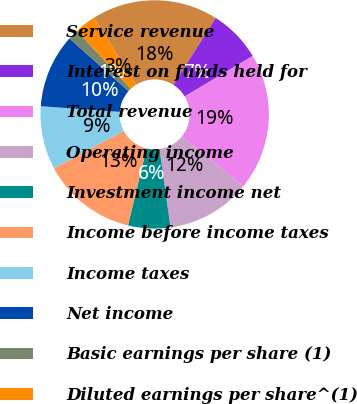Convert chart. <chart><loc_0><loc_0><loc_500><loc_500><pie_chart><fcel>Service revenue<fcel>Interest on funds held for<fcel>Total revenue<fcel>Operating income<fcel>Investment income net<fcel>Income before income taxes<fcel>Income taxes<fcel>Net income<fcel>Basic earnings per share (1)<fcel>Diluted earnings per share^(1)<nl><fcel>17.91%<fcel>7.46%<fcel>19.4%<fcel>11.94%<fcel>5.97%<fcel>13.43%<fcel>8.96%<fcel>10.45%<fcel>1.49%<fcel>2.99%<nl></chart> 